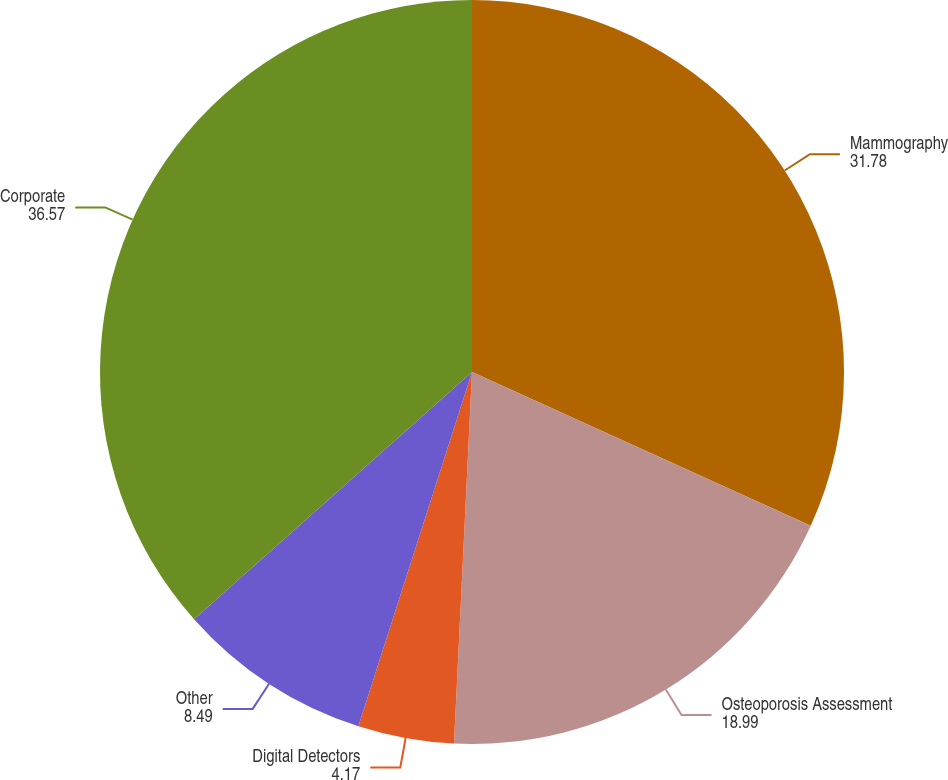Convert chart. <chart><loc_0><loc_0><loc_500><loc_500><pie_chart><fcel>Mammography<fcel>Osteoporosis Assessment<fcel>Digital Detectors<fcel>Other<fcel>Corporate<nl><fcel>31.78%<fcel>18.99%<fcel>4.17%<fcel>8.49%<fcel>36.57%<nl></chart> 